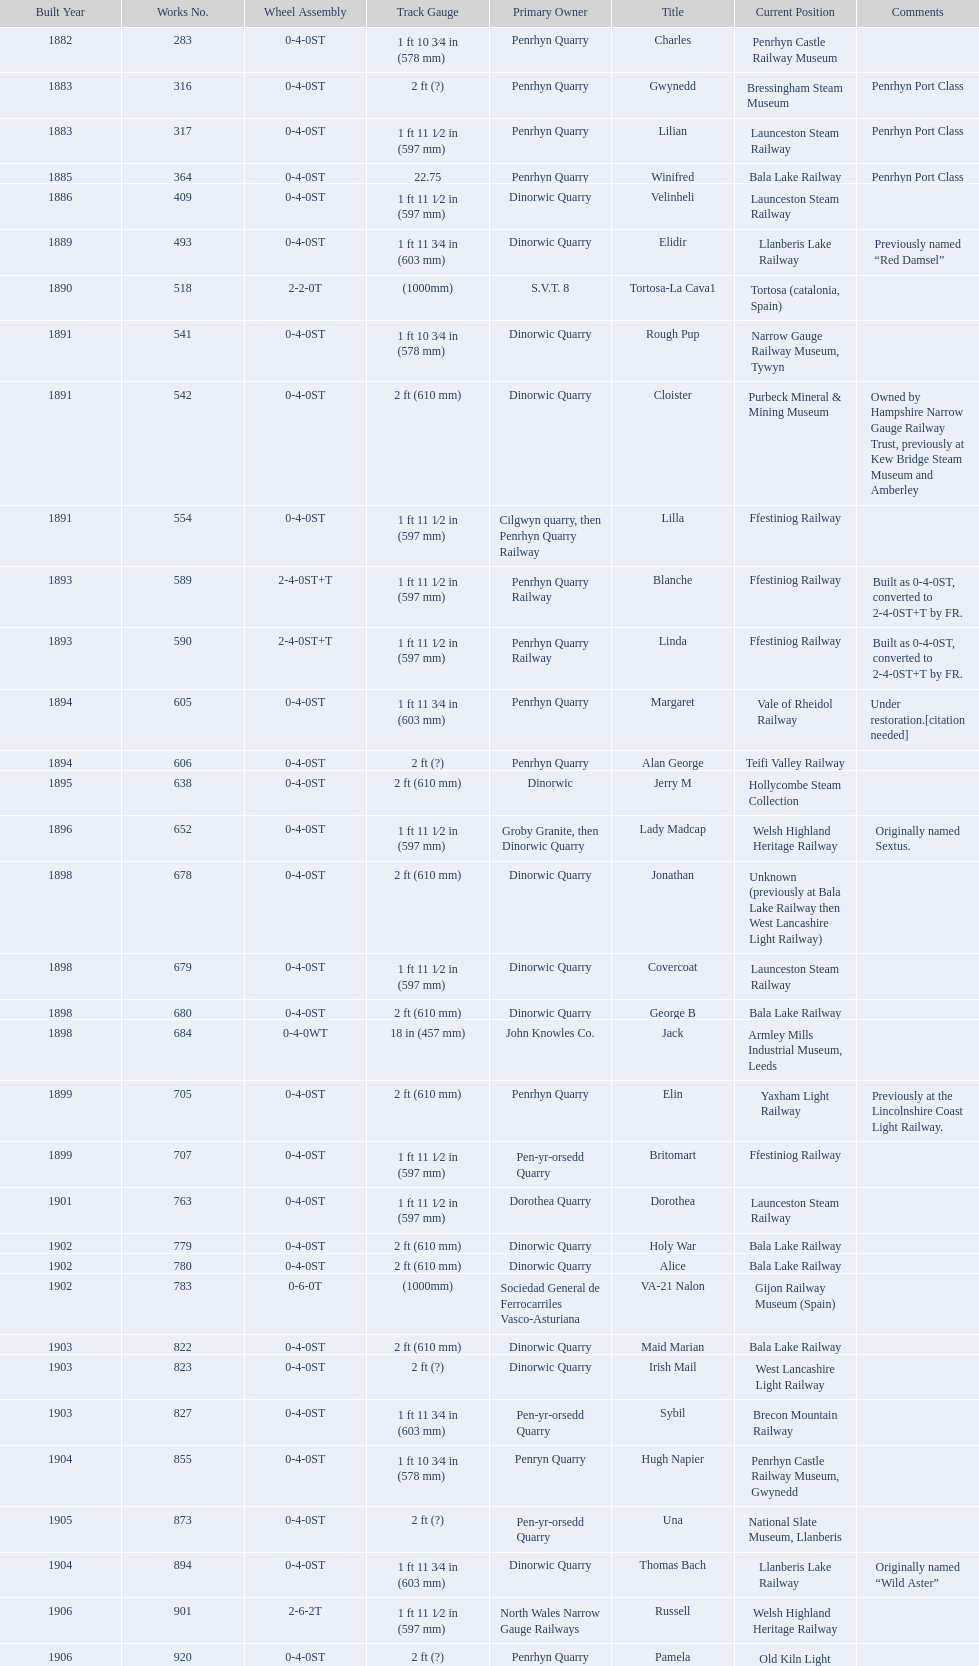What is the total number of preserved hunslet narrow gauge locomotives currently located in ffestiniog railway 554. 